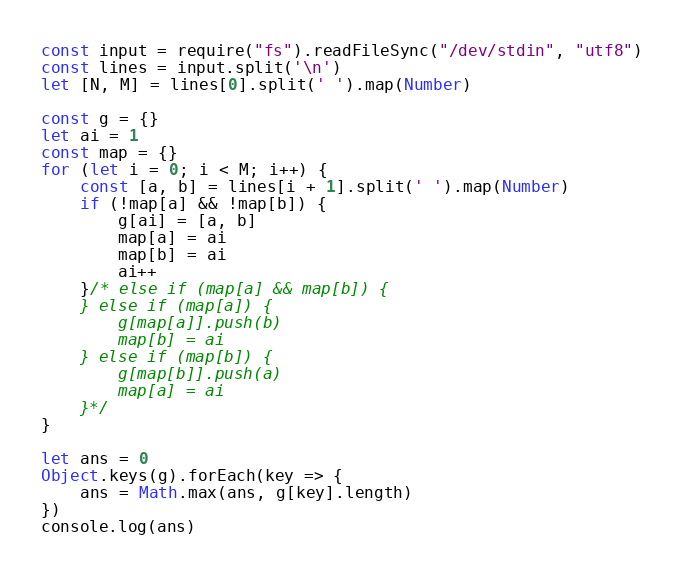<code> <loc_0><loc_0><loc_500><loc_500><_JavaScript_>const input = require("fs").readFileSync("/dev/stdin", "utf8")
const lines = input.split('\n')
let [N, M] = lines[0].split(' ').map(Number)

const g = {}
let ai = 1
const map = {}
for (let i = 0; i < M; i++) {
    const [a, b] = lines[i + 1].split(' ').map(Number)
    if (!map[a] && !map[b]) {
        g[ai] = [a, b]
        map[a] = ai
        map[b] = ai
        ai++
    }/* else if (map[a] && map[b]) {
    } else if (map[a]) {
        g[map[a]].push(b)
        map[b] = ai
    } else if (map[b]) {
        g[map[b]].push(a)
        map[a] = ai
    }*/
}

let ans = 0
Object.keys(g).forEach(key => {
    ans = Math.max(ans, g[key].length)
})
console.log(ans)
</code> 